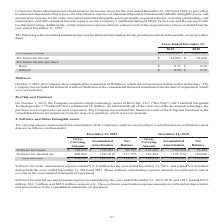According to Aci Worldwide's financial document, What does Walletron deliver? patented mobile wallet technology.. The document states: "leted the acquisition of Walletron, which delivers patented mobile wallet technology. The Company has included the financial results of Walletron in t..." Also, How much did it cost the company to acquire certain technology assets of RevChip, LLC ("RevChip") and TranSend Integrated Technologies Inc. ("TranSend")? According to the financial document, $7.0 million (in millions). The relevant text states: "ated Technologies Inc. ("TranSend") for a combined $7.0 million. As substantially all of the value was in the developed technology, the purchase was recognized as..." Also, What was the pro forma revenue in 2019? According to the financial document, $1,382,957 (in thousands). The relevant text states: "Pro forma revenue $ 1,382,957 $ 1,361,729..." Also, can you calculate: What was the change in pro forma revenue between 2018 and 2019? Based on the calculation: $1,382,957-$1,361,729, the result is 21228 (in thousands). This is based on the information: "Pro forma revenue $ 1,382,957 $ 1,361,729 Pro forma revenue $ 1,382,957 $ 1,361,729..." The key data points involved are: 1,361,729, 1,382,957. Also, can you calculate: What was the change in pro forma net income between 2018 and 2019? Based on the calculation: $82,003-$88,428, the result is -6425 (in thousands). This is based on the information: "Pro forma net income $ 82,003 $ 88,428 Pro forma net income $ 82,003 $ 88,428..." The key data points involved are: 82,003, 88,428. Also, can you calculate: What was the percentage change in pro forma net income between 2018 and 2019? To answer this question, I need to perform calculations using the financial data. The calculation is: ($82,003-$88,428)/$88,428, which equals -7.27 (percentage). This is based on the information: "Pro forma net income $ 82,003 $ 88,428 Pro forma net income $ 82,003 $ 88,428..." The key data points involved are: 82,003, 88,428. 